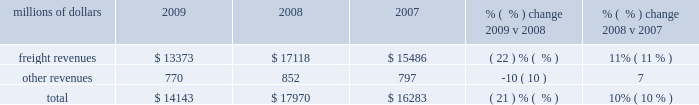Meet customer needs and put us in a position to handle demand changes .
We will also continue utilizing industrial engineering techniques to improve productivity .
2022 fuel prices 2013 uncertainty about the economy makes fuel price projections difficult , and we could see volatile fuel prices during the year , as they are sensitive to global and u.s .
Domestic demand , refining capacity , geopolitical issues and events , weather conditions and other factors .
To reduce the impact of fuel price on earnings , we will continue to seek recovery from our customers through our fuel surcharge programs and to expand our fuel conservation efforts .
2022 capital plan 2013 in 2010 , we plan to make total capital investments of approximately $ 2.5 billion , including expenditures for ptc , which may be revised if business conditions or new laws or regulations affect our ability to generate sufficient returns on these investments .
See further discussion in this item 7 under liquidity and capital resources 2013 capital plan .
2022 positive train control ( ptc ) 2013 in response to a legislative mandate to implement ptc by the end of 2015 , we expect to spend approximately $ 200 million during 2010 on the development of ptc .
We currently estimate that ptc will cost us approximately $ 1.4 billion to implement by the end of 2015 , in accordance with rules issued by the fra .
This includes costs for installing the new system along our tracks , upgrading locomotives to work with the new system , and adding digital data communication equipment so all the parts of the system can communicate with each other .
2022 financial expectations 2013 we remain cautious about economic conditions but expect volume to increase from 2009 levels .
In addition , we anticipate continued pricing opportunities and further productivity improvements .
Results of operations operating revenues millions of dollars 2009 2008 2007 % (  % ) change 2009 v 2008 % (  % ) change 2008 v 2007 .
Freight revenues are revenues generated by transporting freight or other materials from our six commodity groups .
Freight revenues vary with volume ( carloads ) and average revenue per car ( arc ) .
Changes in price , traffic mix and fuel surcharges drive arc .
We provide some of our customers with contractual incentives for meeting or exceeding specified cumulative volumes or shipping to and from specific locations , which we record as a reduction to freight revenues based on the actual or projected future shipments .
We recognize freight revenues on a percentage-of-completion basis as freight moves from origin to destination .
We allocate freight revenues between reporting periods based on the relative transit time in each reporting period and recognize expenses as we incur them .
Other revenues include revenues earned by our subsidiaries , revenues from our commuter rail operations , and accessorial revenues , which we earn when customers retain equipment owned or controlled by us or when we perform additional services such as switching or storage .
We recognize other revenues as we perform services or meet contractual obligations .
Freight revenues and volume levels for all six commodity groups decreased during 2009 , reflecting continued economic weakness .
We experienced the largest volume declines in automotive and industrial .
How much of the 2010 capital expenditures are devoted to expenditures for ptc? 
Computations: (200 / (2.5 * 1000))
Answer: 0.08. Meet customer needs and put us in a position to handle demand changes .
We will also continue utilizing industrial engineering techniques to improve productivity .
2022 fuel prices 2013 uncertainty about the economy makes fuel price projections difficult , and we could see volatile fuel prices during the year , as they are sensitive to global and u.s .
Domestic demand , refining capacity , geopolitical issues and events , weather conditions and other factors .
To reduce the impact of fuel price on earnings , we will continue to seek recovery from our customers through our fuel surcharge programs and to expand our fuel conservation efforts .
2022 capital plan 2013 in 2010 , we plan to make total capital investments of approximately $ 2.5 billion , including expenditures for ptc , which may be revised if business conditions or new laws or regulations affect our ability to generate sufficient returns on these investments .
See further discussion in this item 7 under liquidity and capital resources 2013 capital plan .
2022 positive train control ( ptc ) 2013 in response to a legislative mandate to implement ptc by the end of 2015 , we expect to spend approximately $ 200 million during 2010 on the development of ptc .
We currently estimate that ptc will cost us approximately $ 1.4 billion to implement by the end of 2015 , in accordance with rules issued by the fra .
This includes costs for installing the new system along our tracks , upgrading locomotives to work with the new system , and adding digital data communication equipment so all the parts of the system can communicate with each other .
2022 financial expectations 2013 we remain cautious about economic conditions but expect volume to increase from 2009 levels .
In addition , we anticipate continued pricing opportunities and further productivity improvements .
Results of operations operating revenues millions of dollars 2009 2008 2007 % (  % ) change 2009 v 2008 % (  % ) change 2008 v 2007 .
Freight revenues are revenues generated by transporting freight or other materials from our six commodity groups .
Freight revenues vary with volume ( carloads ) and average revenue per car ( arc ) .
Changes in price , traffic mix and fuel surcharges drive arc .
We provide some of our customers with contractual incentives for meeting or exceeding specified cumulative volumes or shipping to and from specific locations , which we record as a reduction to freight revenues based on the actual or projected future shipments .
We recognize freight revenues on a percentage-of-completion basis as freight moves from origin to destination .
We allocate freight revenues between reporting periods based on the relative transit time in each reporting period and recognize expenses as we incur them .
Other revenues include revenues earned by our subsidiaries , revenues from our commuter rail operations , and accessorial revenues , which we earn when customers retain equipment owned or controlled by us or when we perform additional services such as switching or storage .
We recognize other revenues as we perform services or meet contractual obligations .
Freight revenues and volume levels for all six commodity groups decreased during 2009 , reflecting continued economic weakness .
We experienced the largest volume declines in automotive and industrial .
What was the change in total revenue in millions from 2007 to 2008? 
Computations: (17970 - 16283)
Answer: 1687.0. Meet customer needs and put us in a position to handle demand changes .
We will also continue utilizing industrial engineering techniques to improve productivity .
2022 fuel prices 2013 uncertainty about the economy makes fuel price projections difficult , and we could see volatile fuel prices during the year , as they are sensitive to global and u.s .
Domestic demand , refining capacity , geopolitical issues and events , weather conditions and other factors .
To reduce the impact of fuel price on earnings , we will continue to seek recovery from our customers through our fuel surcharge programs and to expand our fuel conservation efforts .
2022 capital plan 2013 in 2010 , we plan to make total capital investments of approximately $ 2.5 billion , including expenditures for ptc , which may be revised if business conditions or new laws or regulations affect our ability to generate sufficient returns on these investments .
See further discussion in this item 7 under liquidity and capital resources 2013 capital plan .
2022 positive train control ( ptc ) 2013 in response to a legislative mandate to implement ptc by the end of 2015 , we expect to spend approximately $ 200 million during 2010 on the development of ptc .
We currently estimate that ptc will cost us approximately $ 1.4 billion to implement by the end of 2015 , in accordance with rules issued by the fra .
This includes costs for installing the new system along our tracks , upgrading locomotives to work with the new system , and adding digital data communication equipment so all the parts of the system can communicate with each other .
2022 financial expectations 2013 we remain cautious about economic conditions but expect volume to increase from 2009 levels .
In addition , we anticipate continued pricing opportunities and further productivity improvements .
Results of operations operating revenues millions of dollars 2009 2008 2007 % (  % ) change 2009 v 2008 % (  % ) change 2008 v 2007 .
Freight revenues are revenues generated by transporting freight or other materials from our six commodity groups .
Freight revenues vary with volume ( carloads ) and average revenue per car ( arc ) .
Changes in price , traffic mix and fuel surcharges drive arc .
We provide some of our customers with contractual incentives for meeting or exceeding specified cumulative volumes or shipping to and from specific locations , which we record as a reduction to freight revenues based on the actual or projected future shipments .
We recognize freight revenues on a percentage-of-completion basis as freight moves from origin to destination .
We allocate freight revenues between reporting periods based on the relative transit time in each reporting period and recognize expenses as we incur them .
Other revenues include revenues earned by our subsidiaries , revenues from our commuter rail operations , and accessorial revenues , which we earn when customers retain equipment owned or controlled by us or when we perform additional services such as switching or storage .
We recognize other revenues as we perform services or meet contractual obligations .
Freight revenues and volume levels for all six commodity groups decreased during 2009 , reflecting continued economic weakness .
We experienced the largest volume declines in automotive and industrial .
What was the change in total revenue in millions from 2008 to 200? 
Computations: (14143 - 17970)
Answer: -3827.0. 